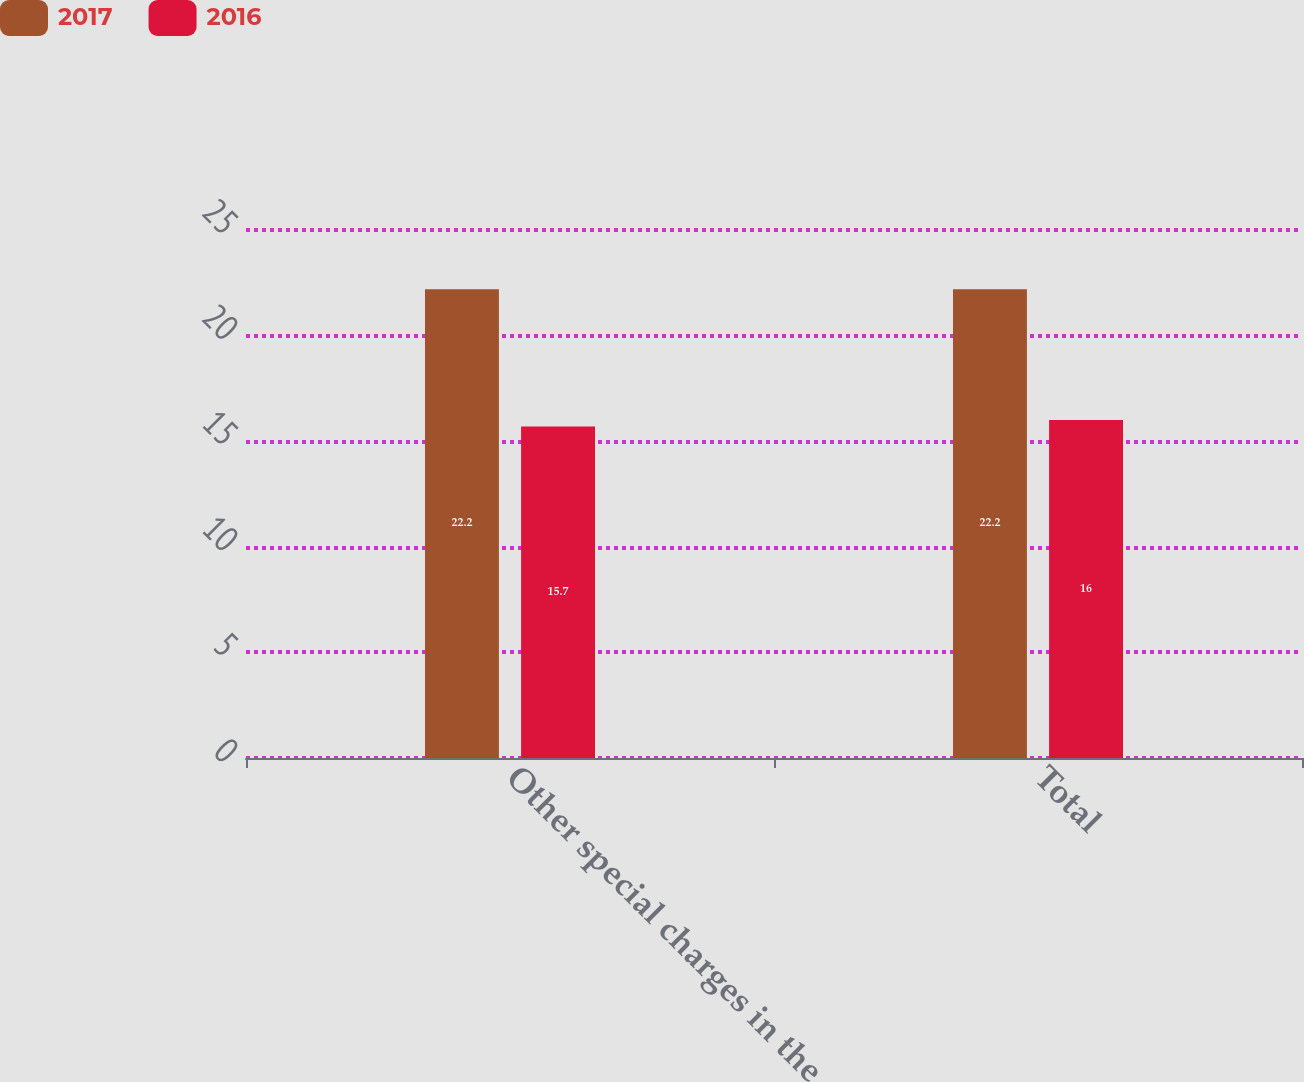<chart> <loc_0><loc_0><loc_500><loc_500><stacked_bar_chart><ecel><fcel>Other special charges in the<fcel>Total<nl><fcel>2017<fcel>22.2<fcel>22.2<nl><fcel>2016<fcel>15.7<fcel>16<nl></chart> 